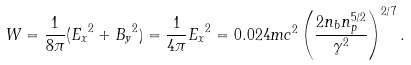<formula> <loc_0><loc_0><loc_500><loc_500>W = \frac { 1 } { 8 \pi } ( { E _ { x } } ^ { 2 } + { B _ { y } } ^ { 2 } ) = \frac { 1 } { 4 \pi } { E _ { x } } ^ { 2 } = 0 . 0 2 4 m c ^ { 2 } \left ( \frac { 2 n _ { b } n _ { p } ^ { 5 / 2 } } { \gamma ^ { 2 } } \right ) ^ { 2 / 7 } .</formula> 